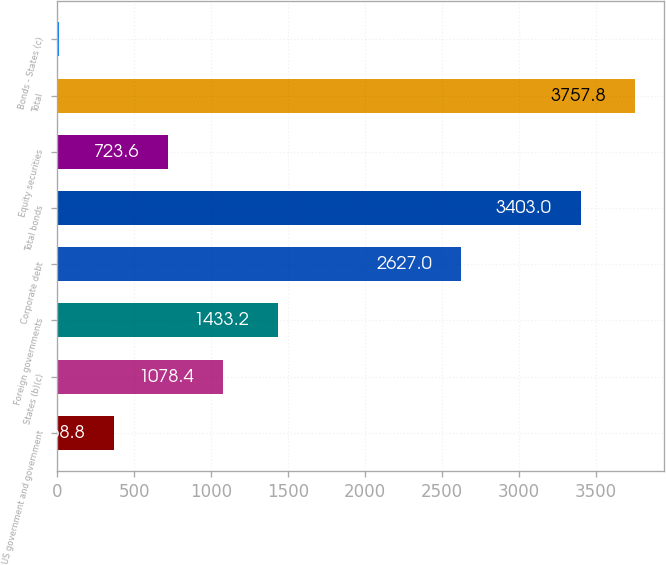Convert chart to OTSL. <chart><loc_0><loc_0><loc_500><loc_500><bar_chart><fcel>US government and government<fcel>States (b)(c)<fcel>Foreign governments<fcel>Corporate debt<fcel>Total bonds<fcel>Equity securities<fcel>Total<fcel>Bonds - States (c)<nl><fcel>368.8<fcel>1078.4<fcel>1433.2<fcel>2627<fcel>3403<fcel>723.6<fcel>3757.8<fcel>14<nl></chart> 